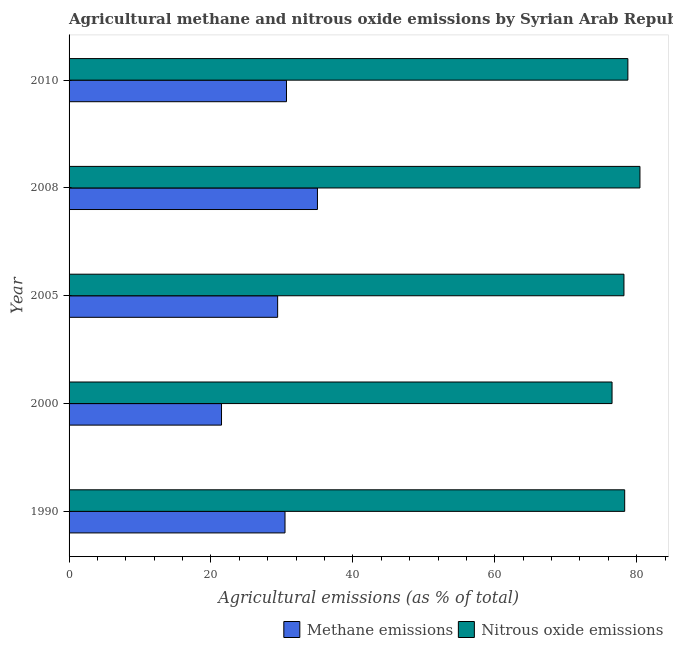How many different coloured bars are there?
Your answer should be very brief. 2. How many groups of bars are there?
Provide a succinct answer. 5. Are the number of bars per tick equal to the number of legend labels?
Your answer should be very brief. Yes. What is the label of the 4th group of bars from the top?
Provide a short and direct response. 2000. In how many cases, is the number of bars for a given year not equal to the number of legend labels?
Your answer should be very brief. 0. What is the amount of nitrous oxide emissions in 1990?
Your answer should be compact. 78.3. Across all years, what is the maximum amount of nitrous oxide emissions?
Offer a terse response. 80.45. Across all years, what is the minimum amount of nitrous oxide emissions?
Make the answer very short. 76.52. In which year was the amount of nitrous oxide emissions maximum?
Ensure brevity in your answer.  2008. What is the total amount of nitrous oxide emissions in the graph?
Keep it short and to the point. 392.23. What is the difference between the amount of methane emissions in 1990 and that in 2008?
Offer a very short reply. -4.57. What is the difference between the amount of nitrous oxide emissions in 2008 and the amount of methane emissions in 1990?
Provide a succinct answer. 50.02. What is the average amount of nitrous oxide emissions per year?
Keep it short and to the point. 78.45. In the year 2008, what is the difference between the amount of nitrous oxide emissions and amount of methane emissions?
Keep it short and to the point. 45.45. In how many years, is the amount of nitrous oxide emissions greater than 32 %?
Provide a succinct answer. 5. Is the amount of nitrous oxide emissions in 1990 less than that in 2010?
Your answer should be very brief. Yes. What is the difference between the highest and the second highest amount of methane emissions?
Make the answer very short. 4.36. What is the difference between the highest and the lowest amount of nitrous oxide emissions?
Provide a succinct answer. 3.93. Is the sum of the amount of methane emissions in 2000 and 2010 greater than the maximum amount of nitrous oxide emissions across all years?
Give a very brief answer. No. What does the 1st bar from the top in 2010 represents?
Ensure brevity in your answer.  Nitrous oxide emissions. What does the 1st bar from the bottom in 2008 represents?
Make the answer very short. Methane emissions. Are all the bars in the graph horizontal?
Keep it short and to the point. Yes. How many years are there in the graph?
Provide a short and direct response. 5. Are the values on the major ticks of X-axis written in scientific E-notation?
Give a very brief answer. No. Does the graph contain any zero values?
Your response must be concise. No. Where does the legend appear in the graph?
Give a very brief answer. Bottom right. How many legend labels are there?
Your answer should be compact. 2. How are the legend labels stacked?
Keep it short and to the point. Horizontal. What is the title of the graph?
Your answer should be compact. Agricultural methane and nitrous oxide emissions by Syrian Arab Republic. Does "Male entrants" appear as one of the legend labels in the graph?
Your answer should be very brief. No. What is the label or title of the X-axis?
Offer a very short reply. Agricultural emissions (as % of total). What is the Agricultural emissions (as % of total) of Methane emissions in 1990?
Give a very brief answer. 30.43. What is the Agricultural emissions (as % of total) in Nitrous oxide emissions in 1990?
Provide a short and direct response. 78.3. What is the Agricultural emissions (as % of total) in Methane emissions in 2000?
Provide a short and direct response. 21.48. What is the Agricultural emissions (as % of total) in Nitrous oxide emissions in 2000?
Your response must be concise. 76.52. What is the Agricultural emissions (as % of total) in Methane emissions in 2005?
Your answer should be very brief. 29.39. What is the Agricultural emissions (as % of total) in Nitrous oxide emissions in 2005?
Ensure brevity in your answer.  78.2. What is the Agricultural emissions (as % of total) of Methane emissions in 2008?
Ensure brevity in your answer.  35. What is the Agricultural emissions (as % of total) of Nitrous oxide emissions in 2008?
Ensure brevity in your answer.  80.45. What is the Agricultural emissions (as % of total) of Methane emissions in 2010?
Provide a succinct answer. 30.64. What is the Agricultural emissions (as % of total) of Nitrous oxide emissions in 2010?
Make the answer very short. 78.75. Across all years, what is the maximum Agricultural emissions (as % of total) of Methane emissions?
Your answer should be compact. 35. Across all years, what is the maximum Agricultural emissions (as % of total) of Nitrous oxide emissions?
Your answer should be very brief. 80.45. Across all years, what is the minimum Agricultural emissions (as % of total) of Methane emissions?
Your answer should be compact. 21.48. Across all years, what is the minimum Agricultural emissions (as % of total) in Nitrous oxide emissions?
Your answer should be very brief. 76.52. What is the total Agricultural emissions (as % of total) in Methane emissions in the graph?
Provide a short and direct response. 146.95. What is the total Agricultural emissions (as % of total) in Nitrous oxide emissions in the graph?
Your response must be concise. 392.23. What is the difference between the Agricultural emissions (as % of total) of Methane emissions in 1990 and that in 2000?
Offer a very short reply. 8.95. What is the difference between the Agricultural emissions (as % of total) in Nitrous oxide emissions in 1990 and that in 2000?
Offer a terse response. 1.78. What is the difference between the Agricultural emissions (as % of total) in Methane emissions in 1990 and that in 2005?
Keep it short and to the point. 1.04. What is the difference between the Agricultural emissions (as % of total) in Nitrous oxide emissions in 1990 and that in 2005?
Your answer should be very brief. 0.1. What is the difference between the Agricultural emissions (as % of total) in Methane emissions in 1990 and that in 2008?
Make the answer very short. -4.57. What is the difference between the Agricultural emissions (as % of total) in Nitrous oxide emissions in 1990 and that in 2008?
Ensure brevity in your answer.  -2.15. What is the difference between the Agricultural emissions (as % of total) of Methane emissions in 1990 and that in 2010?
Provide a short and direct response. -0.21. What is the difference between the Agricultural emissions (as % of total) of Nitrous oxide emissions in 1990 and that in 2010?
Provide a succinct answer. -0.45. What is the difference between the Agricultural emissions (as % of total) in Methane emissions in 2000 and that in 2005?
Offer a terse response. -7.91. What is the difference between the Agricultural emissions (as % of total) of Nitrous oxide emissions in 2000 and that in 2005?
Provide a short and direct response. -1.68. What is the difference between the Agricultural emissions (as % of total) of Methane emissions in 2000 and that in 2008?
Provide a short and direct response. -13.52. What is the difference between the Agricultural emissions (as % of total) in Nitrous oxide emissions in 2000 and that in 2008?
Offer a very short reply. -3.93. What is the difference between the Agricultural emissions (as % of total) in Methane emissions in 2000 and that in 2010?
Make the answer very short. -9.16. What is the difference between the Agricultural emissions (as % of total) of Nitrous oxide emissions in 2000 and that in 2010?
Offer a terse response. -2.23. What is the difference between the Agricultural emissions (as % of total) in Methane emissions in 2005 and that in 2008?
Your answer should be compact. -5.61. What is the difference between the Agricultural emissions (as % of total) in Nitrous oxide emissions in 2005 and that in 2008?
Your response must be concise. -2.25. What is the difference between the Agricultural emissions (as % of total) in Methane emissions in 2005 and that in 2010?
Give a very brief answer. -1.25. What is the difference between the Agricultural emissions (as % of total) of Nitrous oxide emissions in 2005 and that in 2010?
Your response must be concise. -0.55. What is the difference between the Agricultural emissions (as % of total) in Methane emissions in 2008 and that in 2010?
Make the answer very short. 4.36. What is the difference between the Agricultural emissions (as % of total) of Nitrous oxide emissions in 2008 and that in 2010?
Your answer should be very brief. 1.7. What is the difference between the Agricultural emissions (as % of total) in Methane emissions in 1990 and the Agricultural emissions (as % of total) in Nitrous oxide emissions in 2000?
Keep it short and to the point. -46.09. What is the difference between the Agricultural emissions (as % of total) of Methane emissions in 1990 and the Agricultural emissions (as % of total) of Nitrous oxide emissions in 2005?
Give a very brief answer. -47.77. What is the difference between the Agricultural emissions (as % of total) of Methane emissions in 1990 and the Agricultural emissions (as % of total) of Nitrous oxide emissions in 2008?
Keep it short and to the point. -50.02. What is the difference between the Agricultural emissions (as % of total) of Methane emissions in 1990 and the Agricultural emissions (as % of total) of Nitrous oxide emissions in 2010?
Give a very brief answer. -48.32. What is the difference between the Agricultural emissions (as % of total) in Methane emissions in 2000 and the Agricultural emissions (as % of total) in Nitrous oxide emissions in 2005?
Offer a very short reply. -56.72. What is the difference between the Agricultural emissions (as % of total) of Methane emissions in 2000 and the Agricultural emissions (as % of total) of Nitrous oxide emissions in 2008?
Offer a terse response. -58.97. What is the difference between the Agricultural emissions (as % of total) of Methane emissions in 2000 and the Agricultural emissions (as % of total) of Nitrous oxide emissions in 2010?
Ensure brevity in your answer.  -57.27. What is the difference between the Agricultural emissions (as % of total) of Methane emissions in 2005 and the Agricultural emissions (as % of total) of Nitrous oxide emissions in 2008?
Provide a short and direct response. -51.06. What is the difference between the Agricultural emissions (as % of total) in Methane emissions in 2005 and the Agricultural emissions (as % of total) in Nitrous oxide emissions in 2010?
Provide a succinct answer. -49.36. What is the difference between the Agricultural emissions (as % of total) of Methane emissions in 2008 and the Agricultural emissions (as % of total) of Nitrous oxide emissions in 2010?
Make the answer very short. -43.75. What is the average Agricultural emissions (as % of total) in Methane emissions per year?
Your answer should be compact. 29.39. What is the average Agricultural emissions (as % of total) of Nitrous oxide emissions per year?
Give a very brief answer. 78.45. In the year 1990, what is the difference between the Agricultural emissions (as % of total) of Methane emissions and Agricultural emissions (as % of total) of Nitrous oxide emissions?
Give a very brief answer. -47.87. In the year 2000, what is the difference between the Agricultural emissions (as % of total) in Methane emissions and Agricultural emissions (as % of total) in Nitrous oxide emissions?
Your answer should be very brief. -55.04. In the year 2005, what is the difference between the Agricultural emissions (as % of total) of Methane emissions and Agricultural emissions (as % of total) of Nitrous oxide emissions?
Provide a short and direct response. -48.81. In the year 2008, what is the difference between the Agricultural emissions (as % of total) in Methane emissions and Agricultural emissions (as % of total) in Nitrous oxide emissions?
Offer a very short reply. -45.45. In the year 2010, what is the difference between the Agricultural emissions (as % of total) of Methane emissions and Agricultural emissions (as % of total) of Nitrous oxide emissions?
Give a very brief answer. -48.11. What is the ratio of the Agricultural emissions (as % of total) of Methane emissions in 1990 to that in 2000?
Offer a terse response. 1.42. What is the ratio of the Agricultural emissions (as % of total) of Nitrous oxide emissions in 1990 to that in 2000?
Your response must be concise. 1.02. What is the ratio of the Agricultural emissions (as % of total) in Methane emissions in 1990 to that in 2005?
Provide a succinct answer. 1.04. What is the ratio of the Agricultural emissions (as % of total) of Nitrous oxide emissions in 1990 to that in 2005?
Make the answer very short. 1. What is the ratio of the Agricultural emissions (as % of total) of Methane emissions in 1990 to that in 2008?
Your answer should be compact. 0.87. What is the ratio of the Agricultural emissions (as % of total) in Nitrous oxide emissions in 1990 to that in 2008?
Provide a succinct answer. 0.97. What is the ratio of the Agricultural emissions (as % of total) in Methane emissions in 1990 to that in 2010?
Your answer should be compact. 0.99. What is the ratio of the Agricultural emissions (as % of total) of Nitrous oxide emissions in 1990 to that in 2010?
Your answer should be very brief. 0.99. What is the ratio of the Agricultural emissions (as % of total) of Methane emissions in 2000 to that in 2005?
Offer a terse response. 0.73. What is the ratio of the Agricultural emissions (as % of total) of Nitrous oxide emissions in 2000 to that in 2005?
Keep it short and to the point. 0.98. What is the ratio of the Agricultural emissions (as % of total) in Methane emissions in 2000 to that in 2008?
Your response must be concise. 0.61. What is the ratio of the Agricultural emissions (as % of total) of Nitrous oxide emissions in 2000 to that in 2008?
Provide a succinct answer. 0.95. What is the ratio of the Agricultural emissions (as % of total) in Methane emissions in 2000 to that in 2010?
Give a very brief answer. 0.7. What is the ratio of the Agricultural emissions (as % of total) of Nitrous oxide emissions in 2000 to that in 2010?
Provide a succinct answer. 0.97. What is the ratio of the Agricultural emissions (as % of total) of Methane emissions in 2005 to that in 2008?
Make the answer very short. 0.84. What is the ratio of the Agricultural emissions (as % of total) of Methane emissions in 2005 to that in 2010?
Offer a terse response. 0.96. What is the ratio of the Agricultural emissions (as % of total) of Nitrous oxide emissions in 2005 to that in 2010?
Ensure brevity in your answer.  0.99. What is the ratio of the Agricultural emissions (as % of total) of Methane emissions in 2008 to that in 2010?
Ensure brevity in your answer.  1.14. What is the ratio of the Agricultural emissions (as % of total) of Nitrous oxide emissions in 2008 to that in 2010?
Your answer should be compact. 1.02. What is the difference between the highest and the second highest Agricultural emissions (as % of total) of Methane emissions?
Your answer should be very brief. 4.36. What is the difference between the highest and the second highest Agricultural emissions (as % of total) in Nitrous oxide emissions?
Provide a succinct answer. 1.7. What is the difference between the highest and the lowest Agricultural emissions (as % of total) in Methane emissions?
Make the answer very short. 13.52. What is the difference between the highest and the lowest Agricultural emissions (as % of total) of Nitrous oxide emissions?
Provide a succinct answer. 3.93. 